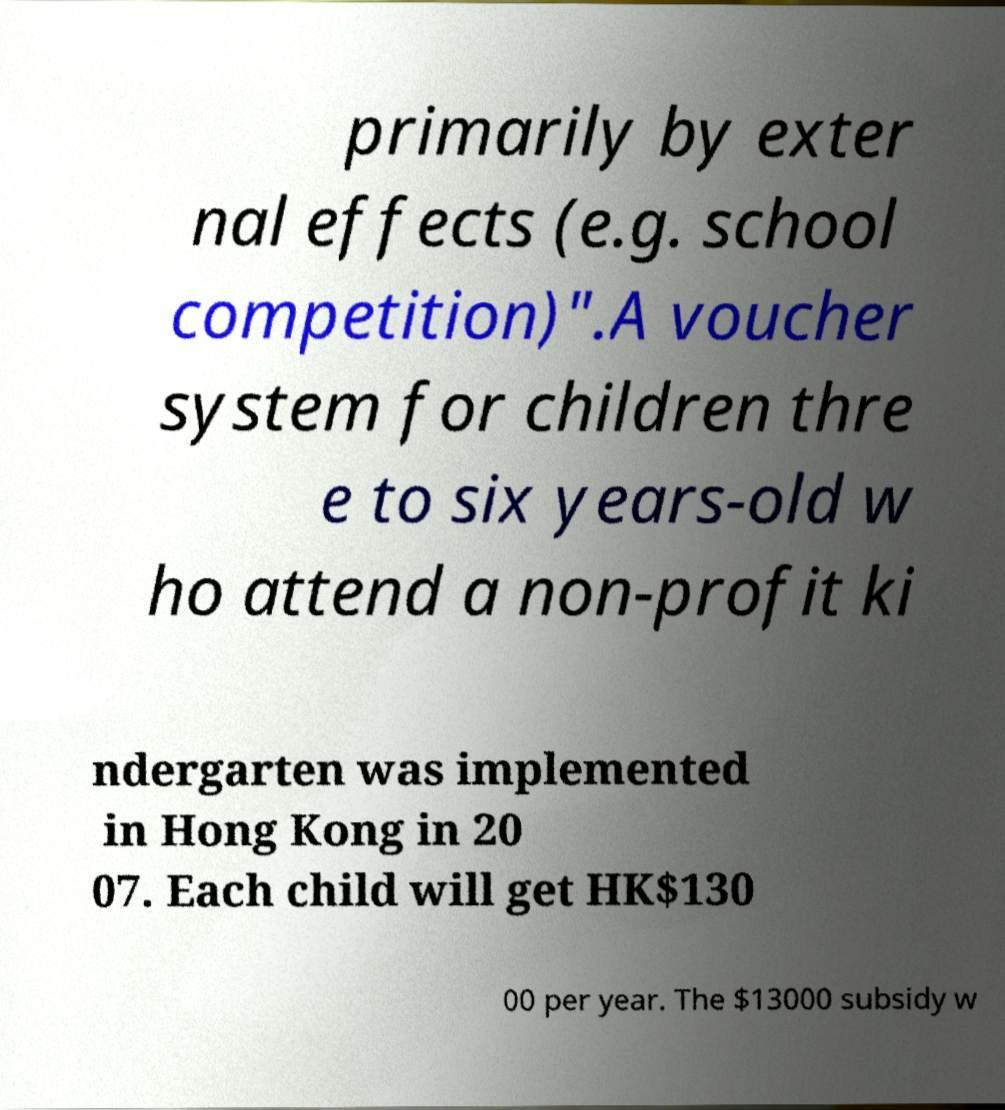For documentation purposes, I need the text within this image transcribed. Could you provide that? primarily by exter nal effects (e.g. school competition)".A voucher system for children thre e to six years-old w ho attend a non-profit ki ndergarten was implemented in Hong Kong in 20 07. Each child will get HK$130 00 per year. The $13000 subsidy w 